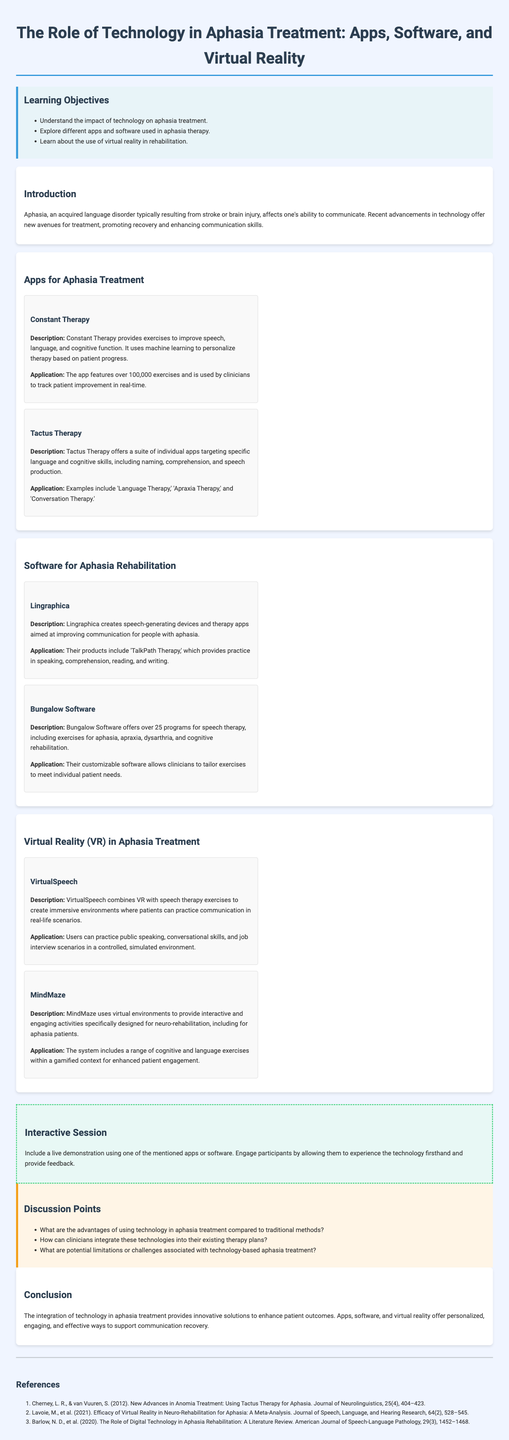What are the learning objectives? The learning objectives are found in the document's section titled 'Learning Objectives', outlining the key areas of focus for the lesson.
Answer: Understand the impact of technology on aphasia treatment, explore different apps and software used in aphasia therapy, learn about the use of virtual reality in rehabilitation What is Constant Therapy? Constant Therapy is mentioned under 'Apps for Aphasia Treatment' and is described in detail concerning its features and application.
Answer: An app providing exercises to improve speech, language, and cognitive function How many exercises does Constant Therapy offer? The document states that Constant Therapy features over 100,000 exercises, reflecting its extensive content for therapy practice.
Answer: Over 100,000 exercises What type of devices does Lingraphica create? Lingraphica is discussed in the 'Software for Aphasia Rehabilitation' section, where its product offerings are described.
Answer: Speech-generating devices What is the purpose of VirtualSpeech? The purpose of VirtualSpeech is described within the 'Virtual Reality in Aphasia Treatment' section, focusing on its role in communication practice.
Answer: Combining VR with speech therapy exercises What is one advantage of using technology in aphasia treatment? This question encourages reasoning based on the discussion points listed, prompting the participant to think critically about technology's benefits.
Answer: Enhanced patient engagement Which app focuses on specific language skills? The document provides details on various apps, specifying which target language skills in their descriptions.
Answer: Tactus Therapy What is the main goal of the interactive session? The interactive session aims to engage participants actively and provide an experiential understanding of the technology discussed.
Answer: Live demonstration using one of the mentioned apps or software 